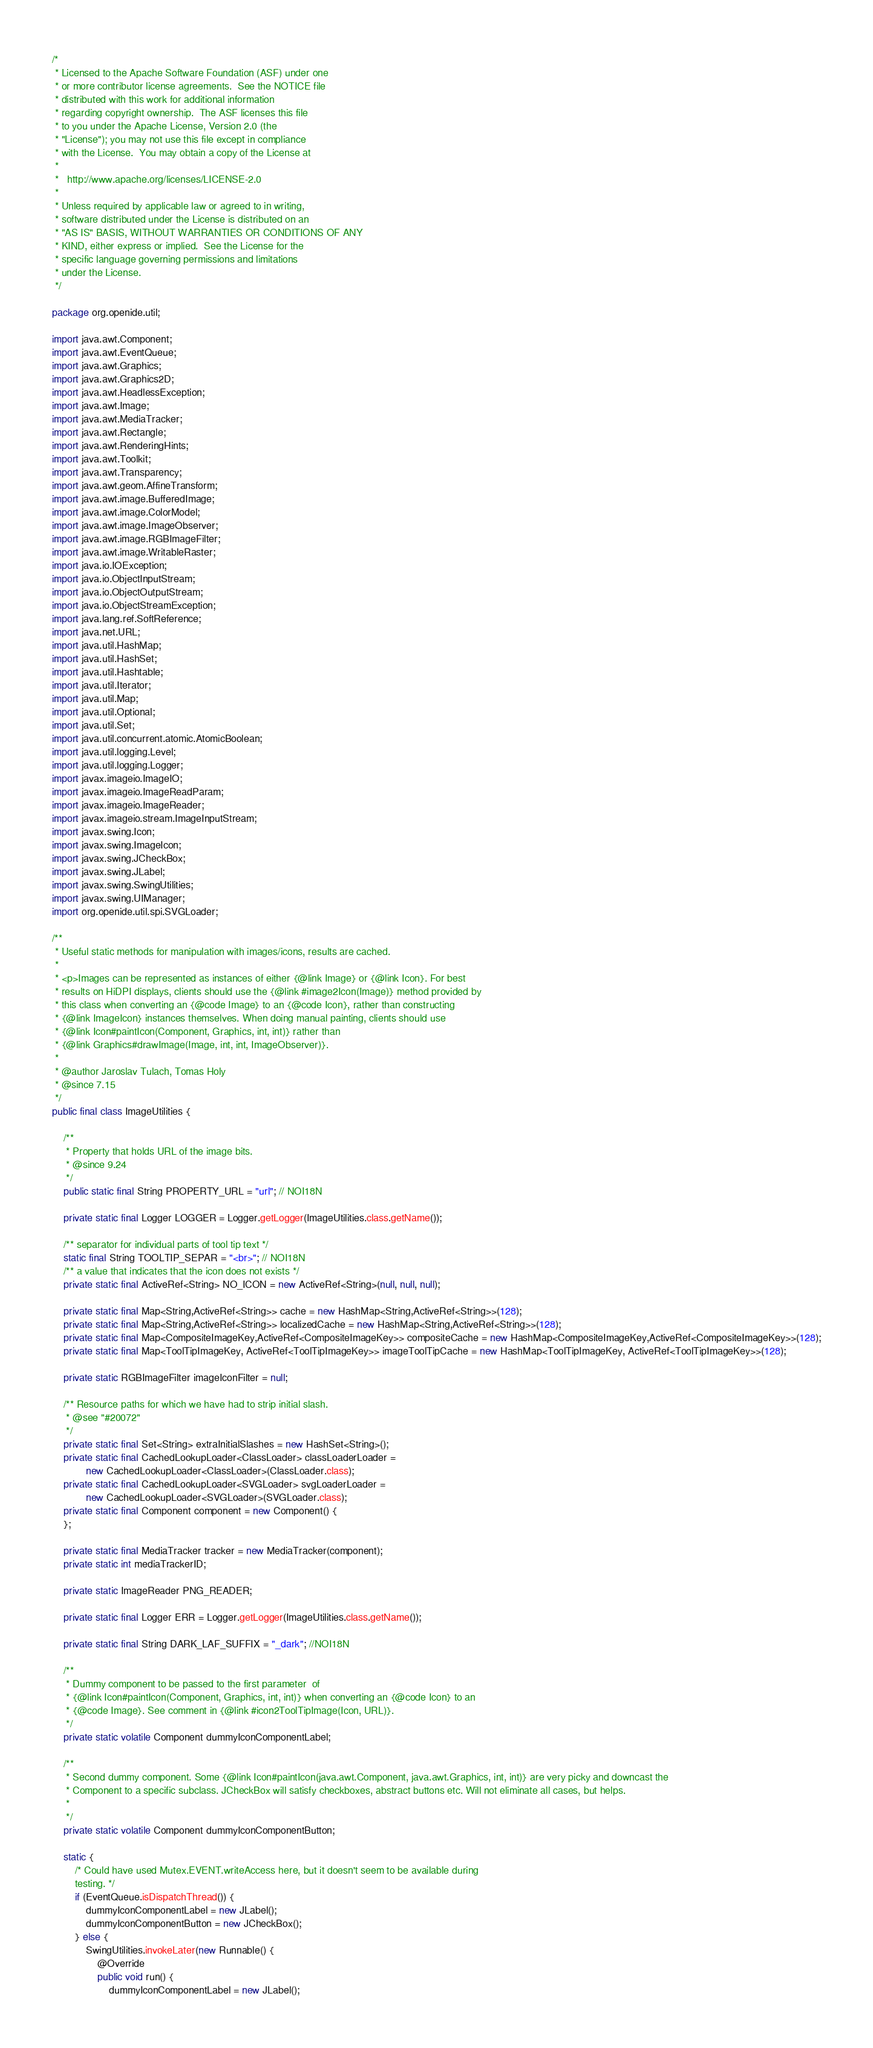<code> <loc_0><loc_0><loc_500><loc_500><_Java_>/*
 * Licensed to the Apache Software Foundation (ASF) under one
 * or more contributor license agreements.  See the NOTICE file
 * distributed with this work for additional information
 * regarding copyright ownership.  The ASF licenses this file
 * to you under the Apache License, Version 2.0 (the
 * "License"); you may not use this file except in compliance
 * with the License.  You may obtain a copy of the License at
 *
 *   http://www.apache.org/licenses/LICENSE-2.0
 *
 * Unless required by applicable law or agreed to in writing,
 * software distributed under the License is distributed on an
 * "AS IS" BASIS, WITHOUT WARRANTIES OR CONDITIONS OF ANY
 * KIND, either express or implied.  See the License for the
 * specific language governing permissions and limitations
 * under the License.
 */

package org.openide.util;

import java.awt.Component;
import java.awt.EventQueue;
import java.awt.Graphics;
import java.awt.Graphics2D;
import java.awt.HeadlessException;
import java.awt.Image;
import java.awt.MediaTracker;
import java.awt.Rectangle;
import java.awt.RenderingHints;
import java.awt.Toolkit;
import java.awt.Transparency;
import java.awt.geom.AffineTransform;
import java.awt.image.BufferedImage;
import java.awt.image.ColorModel;
import java.awt.image.ImageObserver;
import java.awt.image.RGBImageFilter;
import java.awt.image.WritableRaster;
import java.io.IOException;
import java.io.ObjectInputStream;
import java.io.ObjectOutputStream;
import java.io.ObjectStreamException;
import java.lang.ref.SoftReference;
import java.net.URL;
import java.util.HashMap;
import java.util.HashSet;
import java.util.Hashtable;
import java.util.Iterator;
import java.util.Map;
import java.util.Optional;
import java.util.Set;
import java.util.concurrent.atomic.AtomicBoolean;
import java.util.logging.Level;
import java.util.logging.Logger;
import javax.imageio.ImageIO;
import javax.imageio.ImageReadParam;
import javax.imageio.ImageReader;
import javax.imageio.stream.ImageInputStream;
import javax.swing.Icon;
import javax.swing.ImageIcon;
import javax.swing.JCheckBox;
import javax.swing.JLabel;
import javax.swing.SwingUtilities;
import javax.swing.UIManager;
import org.openide.util.spi.SVGLoader;

/** 
 * Useful static methods for manipulation with images/icons, results are cached.
 *
 * <p>Images can be represented as instances of either {@link Image} or {@link Icon}. For best
 * results on HiDPI displays, clients should use the {@link #image2Icon(Image)} method provided by
 * this class when converting an {@code Image} to an {@code Icon}, rather than constructing
 * {@link ImageIcon} instances themselves. When doing manual painting, clients should use
 * {@link Icon#paintIcon(Component, Graphics, int, int)} rather than
 * {@link Graphics#drawImage(Image, int, int, ImageObserver)}.
 * 
 * @author Jaroslav Tulach, Tomas Holy
 * @since 7.15
 */
public final class ImageUtilities {

    /**
     * Property that holds URL of the image bits.
     * @since 9.24
     */
    public static final String PROPERTY_URL = "url"; // NOI18N
    
    private static final Logger LOGGER = Logger.getLogger(ImageUtilities.class.getName());

    /** separator for individual parts of tool tip text */
    static final String TOOLTIP_SEPAR = "<br>"; // NOI18N
    /** a value that indicates that the icon does not exists */
    private static final ActiveRef<String> NO_ICON = new ActiveRef<String>(null, null, null);

    private static final Map<String,ActiveRef<String>> cache = new HashMap<String,ActiveRef<String>>(128);
    private static final Map<String,ActiveRef<String>> localizedCache = new HashMap<String,ActiveRef<String>>(128);
    private static final Map<CompositeImageKey,ActiveRef<CompositeImageKey>> compositeCache = new HashMap<CompositeImageKey,ActiveRef<CompositeImageKey>>(128);
    private static final Map<ToolTipImageKey, ActiveRef<ToolTipImageKey>> imageToolTipCache = new HashMap<ToolTipImageKey, ActiveRef<ToolTipImageKey>>(128);

    private static RGBImageFilter imageIconFilter = null;

    /** Resource paths for which we have had to strip initial slash.
     * @see "#20072"
     */
    private static final Set<String> extraInitialSlashes = new HashSet<String>();
    private static final CachedLookupLoader<ClassLoader> classLoaderLoader =
            new CachedLookupLoader<ClassLoader>(ClassLoader.class);
    private static final CachedLookupLoader<SVGLoader> svgLoaderLoader =
            new CachedLookupLoader<SVGLoader>(SVGLoader.class);
    private static final Component component = new Component() {
    };

    private static final MediaTracker tracker = new MediaTracker(component);
    private static int mediaTrackerID;
    
    private static ImageReader PNG_READER;
    
    private static final Logger ERR = Logger.getLogger(ImageUtilities.class.getName());
    
    private static final String DARK_LAF_SUFFIX = "_dark"; //NOI18N

    /**
     * Dummy component to be passed to the first parameter  of
     * {@link Icon#paintIcon(Component, Graphics, int, int)} when converting an {@code Icon} to an
     * {@code Image}. See comment in {@link #icon2ToolTipImage(Icon, URL)}.
     */
    private static volatile Component dummyIconComponentLabel;

    /**
     * Second dummy component. Some {@link Icon#paintIcon(java.awt.Component, java.awt.Graphics, int, int)} are very picky and downcast the
     * Component to a specific subclass. JCheckBox will satisfy checkboxes, abstract buttons etc. Will not eliminate all cases, but helps.
     * 
     */
    private static volatile Component dummyIconComponentButton;

    static {
        /* Could have used Mutex.EVENT.writeAccess here, but it doesn't seem to be available during
        testing. */
        if (EventQueue.isDispatchThread()) {
            dummyIconComponentLabel = new JLabel();
            dummyIconComponentButton = new JCheckBox();
        } else {
            SwingUtilities.invokeLater(new Runnable() {
                @Override
                public void run() {
                    dummyIconComponentLabel = new JLabel();</code> 